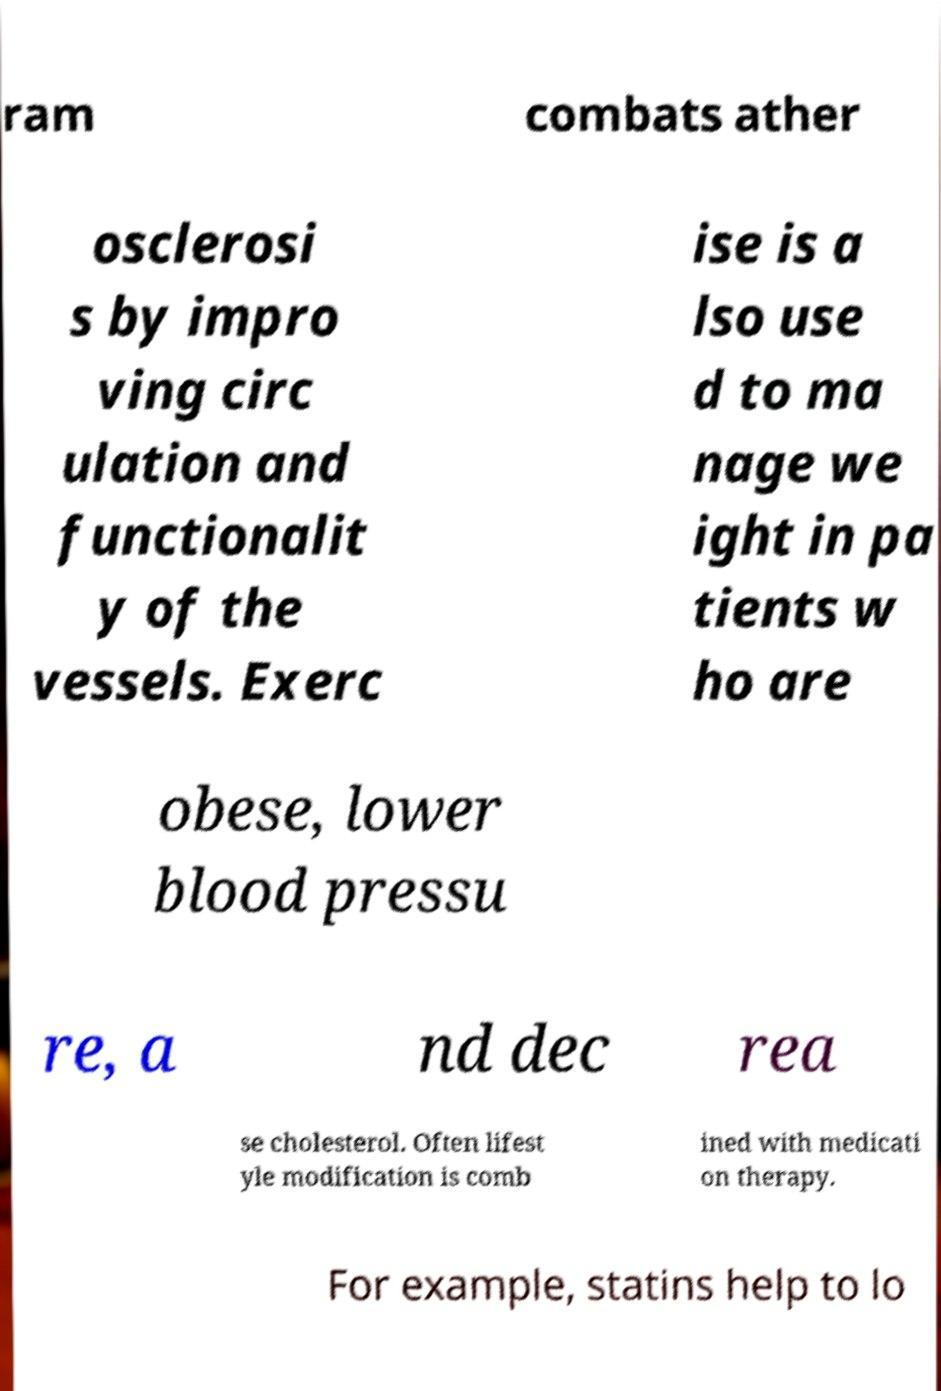Could you assist in decoding the text presented in this image and type it out clearly? ram combats ather osclerosi s by impro ving circ ulation and functionalit y of the vessels. Exerc ise is a lso use d to ma nage we ight in pa tients w ho are obese, lower blood pressu re, a nd dec rea se cholesterol. Often lifest yle modification is comb ined with medicati on therapy. For example, statins help to lo 